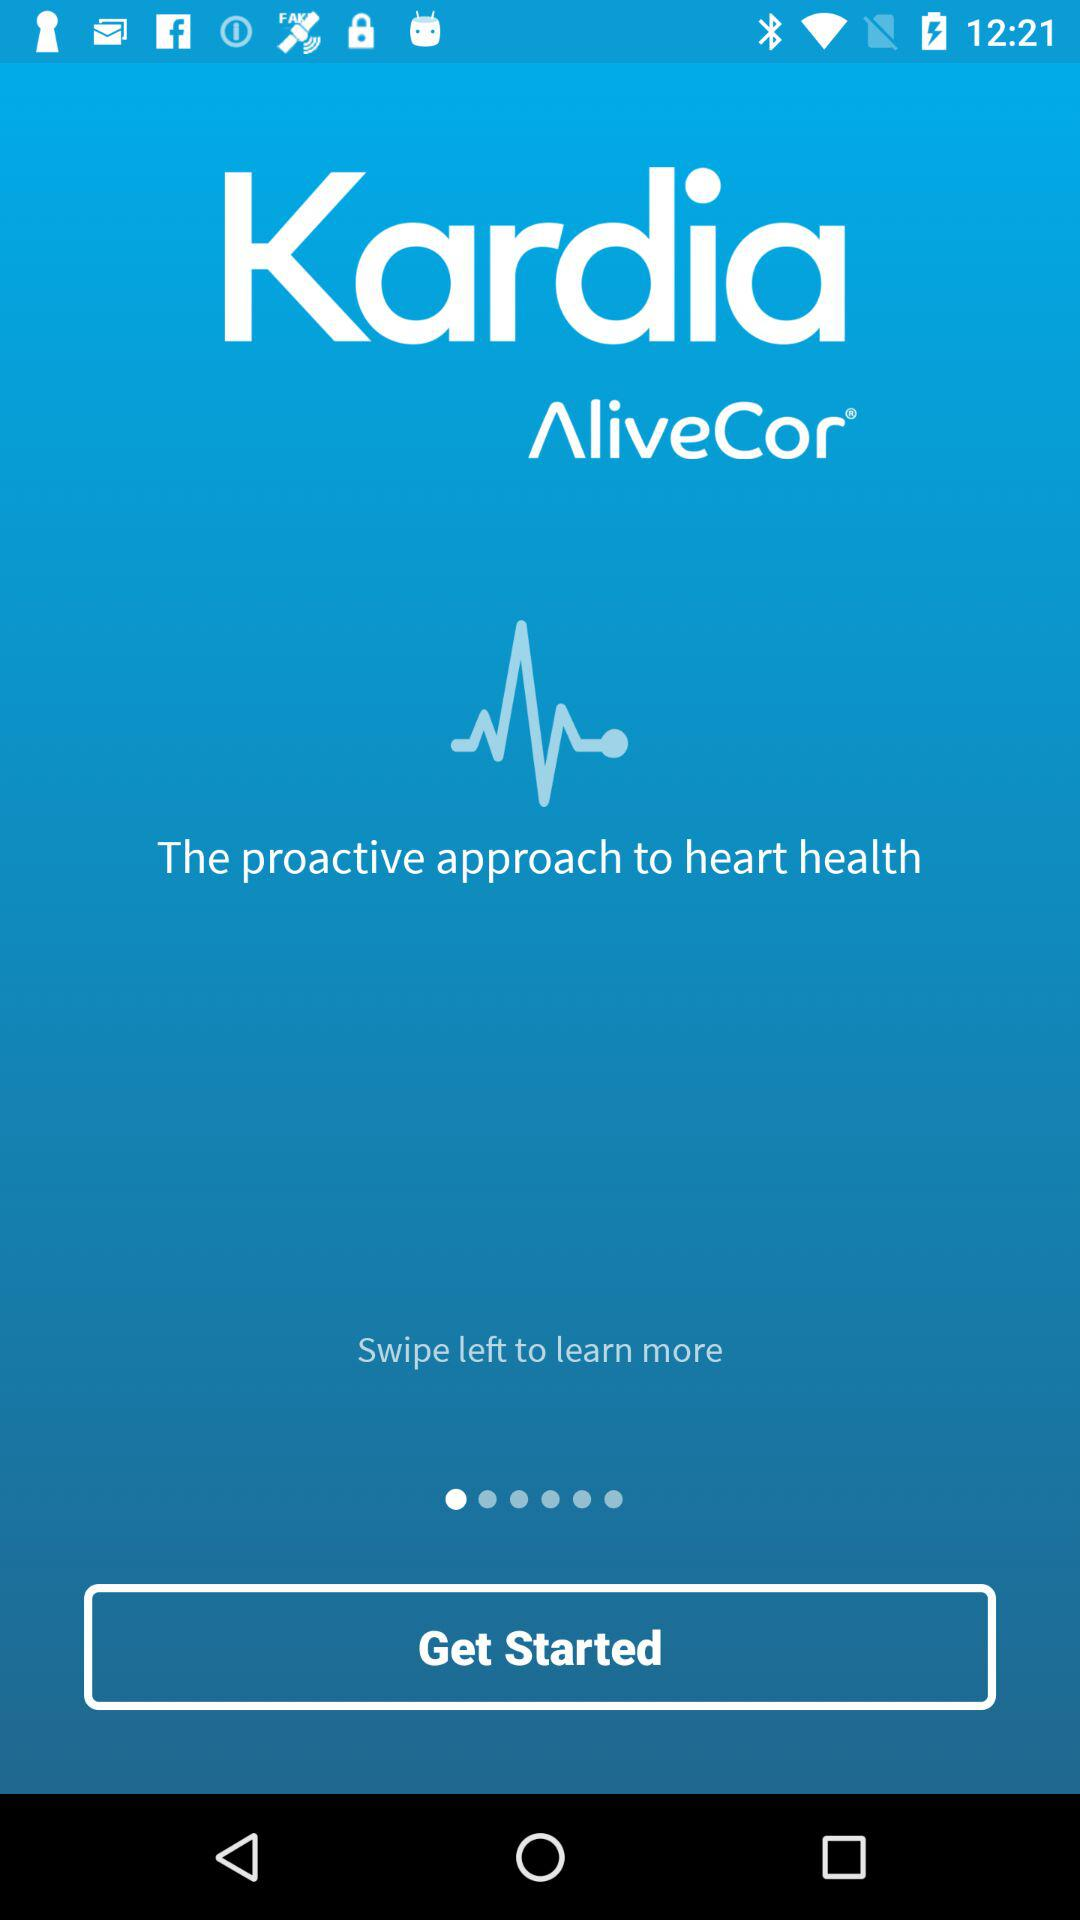Where do we have to swipe to learn more? You have to swipe left to learn more. 